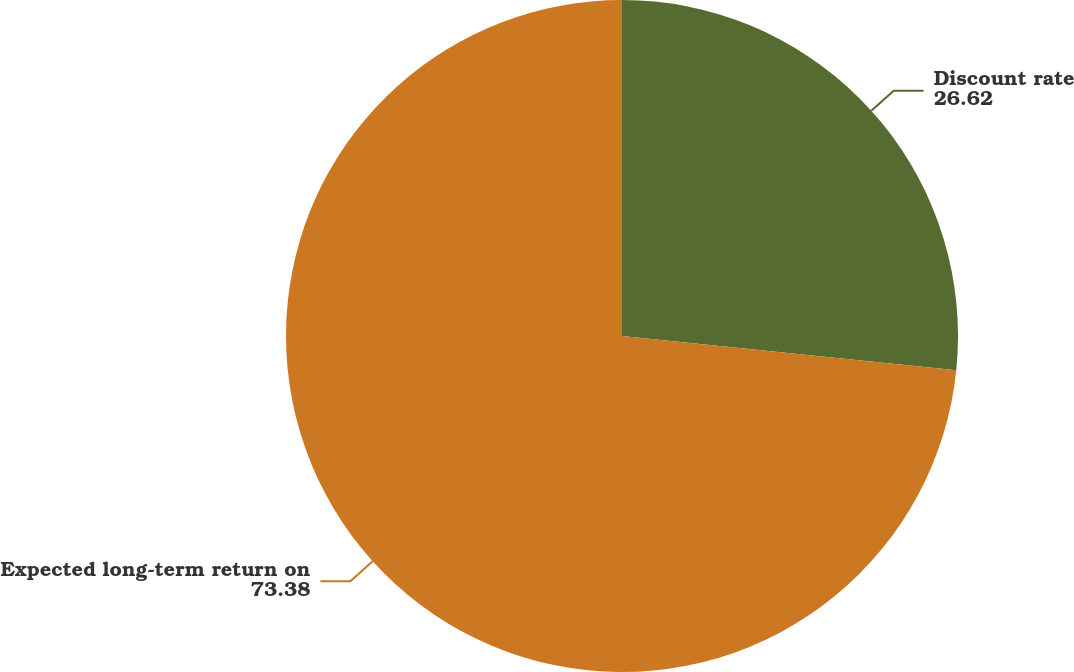Convert chart to OTSL. <chart><loc_0><loc_0><loc_500><loc_500><pie_chart><fcel>Discount rate<fcel>Expected long-term return on<nl><fcel>26.62%<fcel>73.38%<nl></chart> 